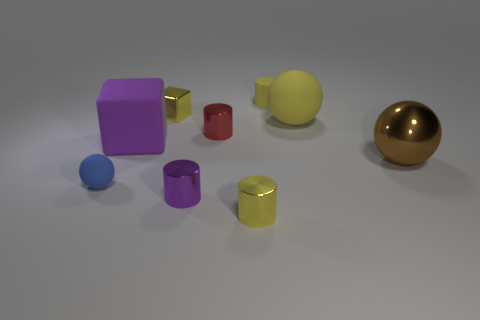Add 1 big matte things. How many objects exist? 10 Subtract all shiny cylinders. How many cylinders are left? 1 Subtract all blue balls. How many balls are left? 2 Subtract all blocks. How many objects are left? 7 Subtract all blue balls. How many purple cylinders are left? 1 Add 6 small cylinders. How many small cylinders exist? 10 Subtract 1 yellow balls. How many objects are left? 8 Subtract 2 balls. How many balls are left? 1 Subtract all cyan cylinders. Subtract all purple balls. How many cylinders are left? 4 Subtract all brown shiny objects. Subtract all tiny yellow rubber cylinders. How many objects are left? 7 